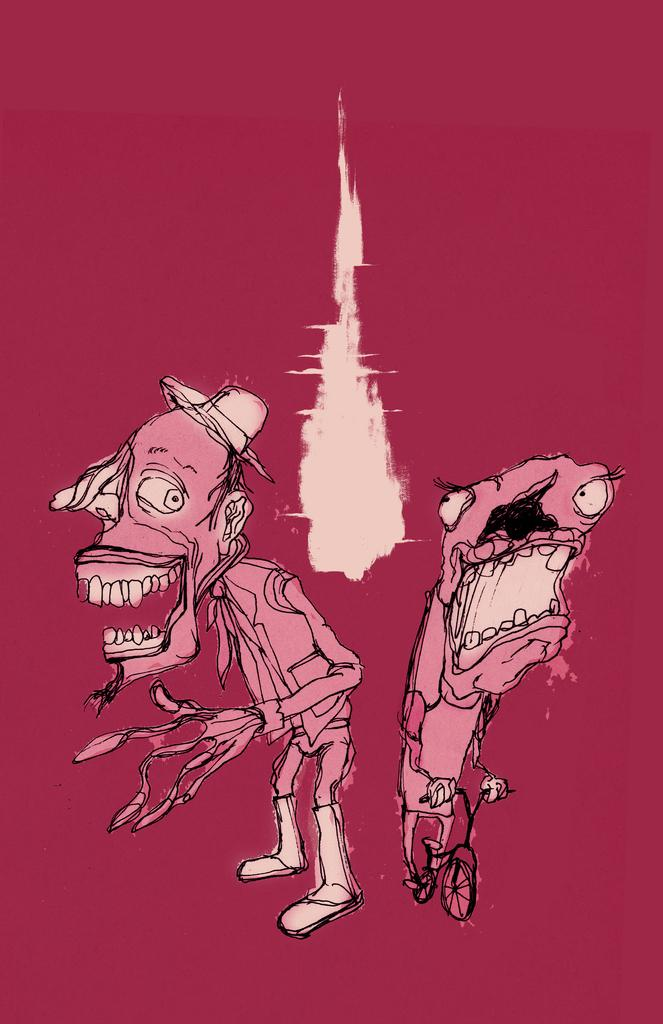What is the main subject of the image? There is a drawing in the image. What color is the drawing? The drawing is in pink color. What type of images are included in the drawing? The drawing contains cartoon images. Can you describe any specific object depicted in the drawing? Yes, there is a cycle depicted in the drawing. What type of noise can be heard coming from the cycle in the drawing? There is no noise present in the image, as it is a drawing and not a real-life scene. 